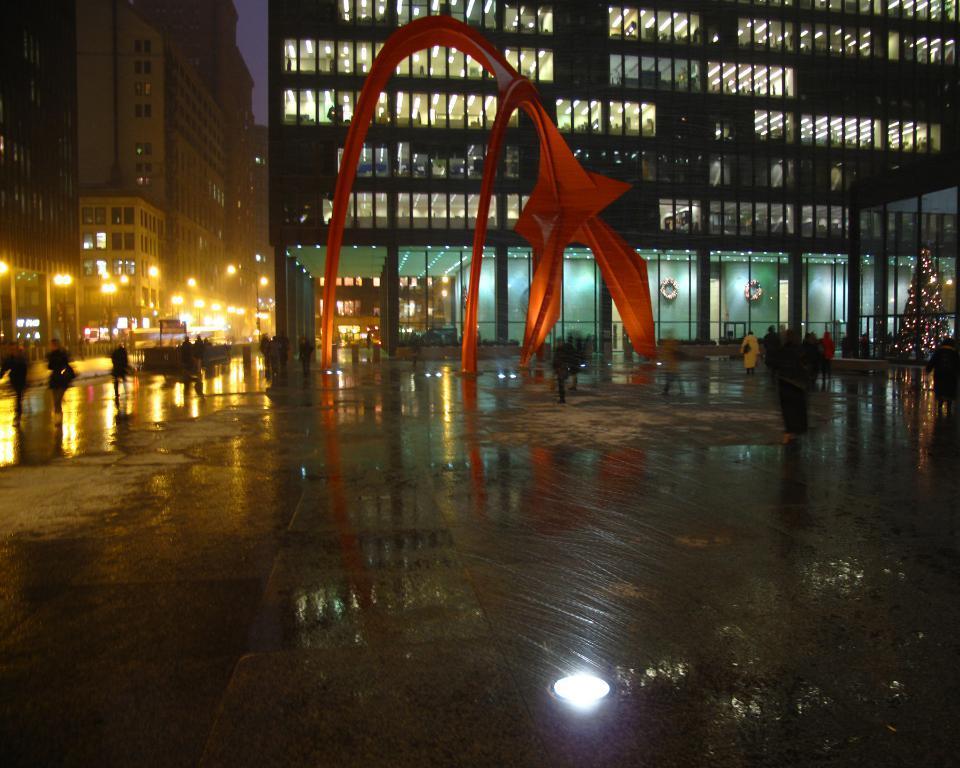How would you summarize this image in a sentence or two? In this image there is a modern sculpture, buildings, lights , poles, there are group of people walking, a tree decorated with lights,and there is sky. 